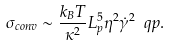<formula> <loc_0><loc_0><loc_500><loc_500>\sigma _ { c o n v } \sim \frac { k _ { B } T } { \kappa ^ { 2 } } L _ { p } ^ { 5 } \eta ^ { 2 } \dot { \gamma } ^ { 2 } \ q p .</formula> 